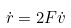<formula> <loc_0><loc_0><loc_500><loc_500>\dot { r } = 2 F \dot { v }</formula> 